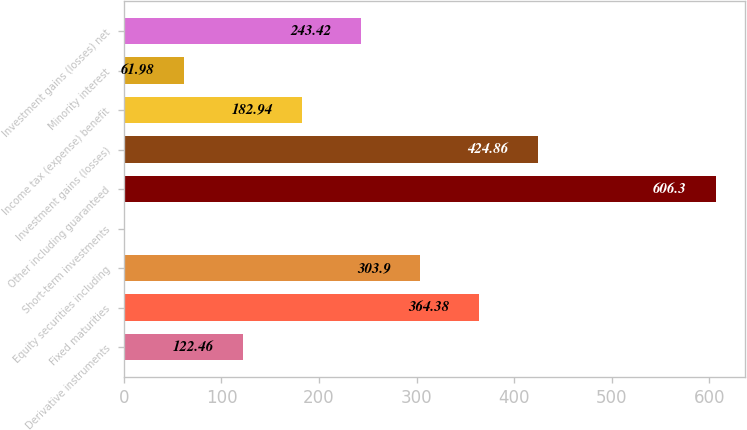<chart> <loc_0><loc_0><loc_500><loc_500><bar_chart><fcel>Derivative instruments<fcel>Fixed maturities<fcel>Equity securities including<fcel>Short-term investments<fcel>Other including guaranteed<fcel>Investment gains (losses)<fcel>Income tax (expense) benefit<fcel>Minority interest<fcel>Investment gains (losses) net<nl><fcel>122.46<fcel>364.38<fcel>303.9<fcel>1.5<fcel>606.3<fcel>424.86<fcel>182.94<fcel>61.98<fcel>243.42<nl></chart> 